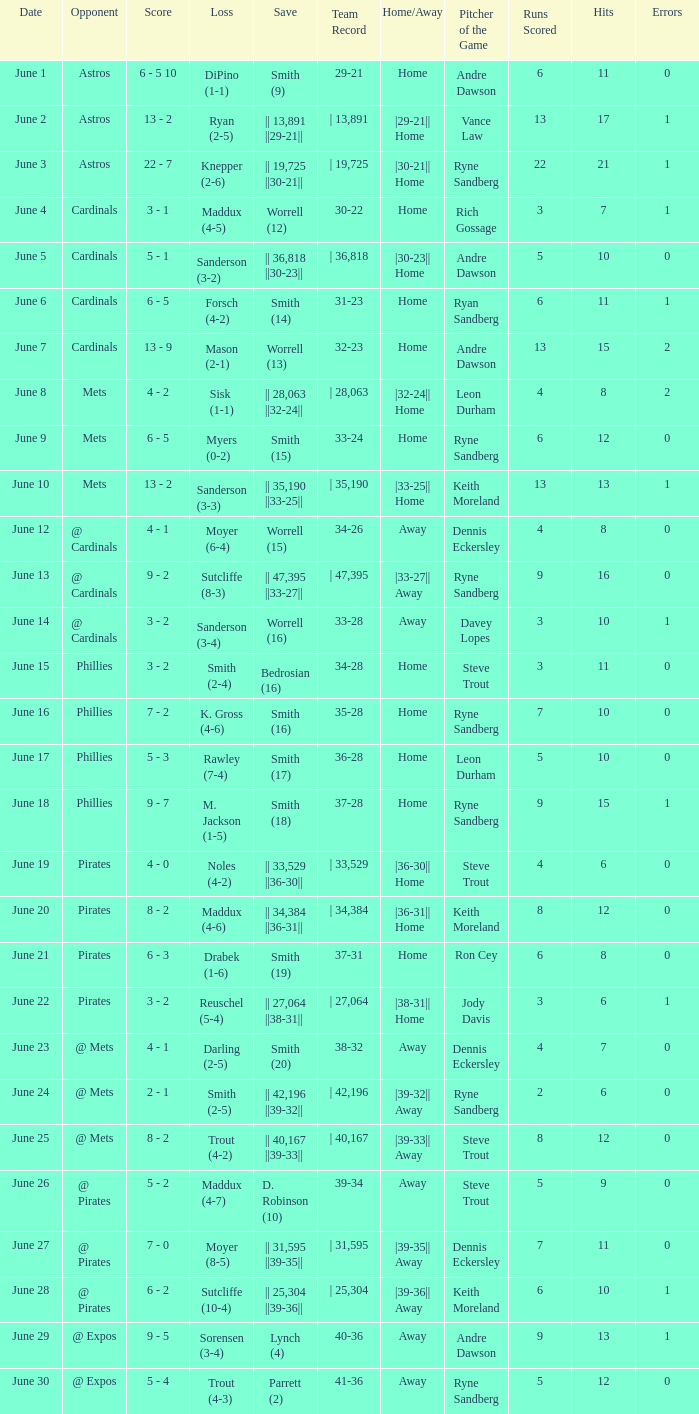The game with a loss of smith (2-4) ended with what score? 3 - 2. 